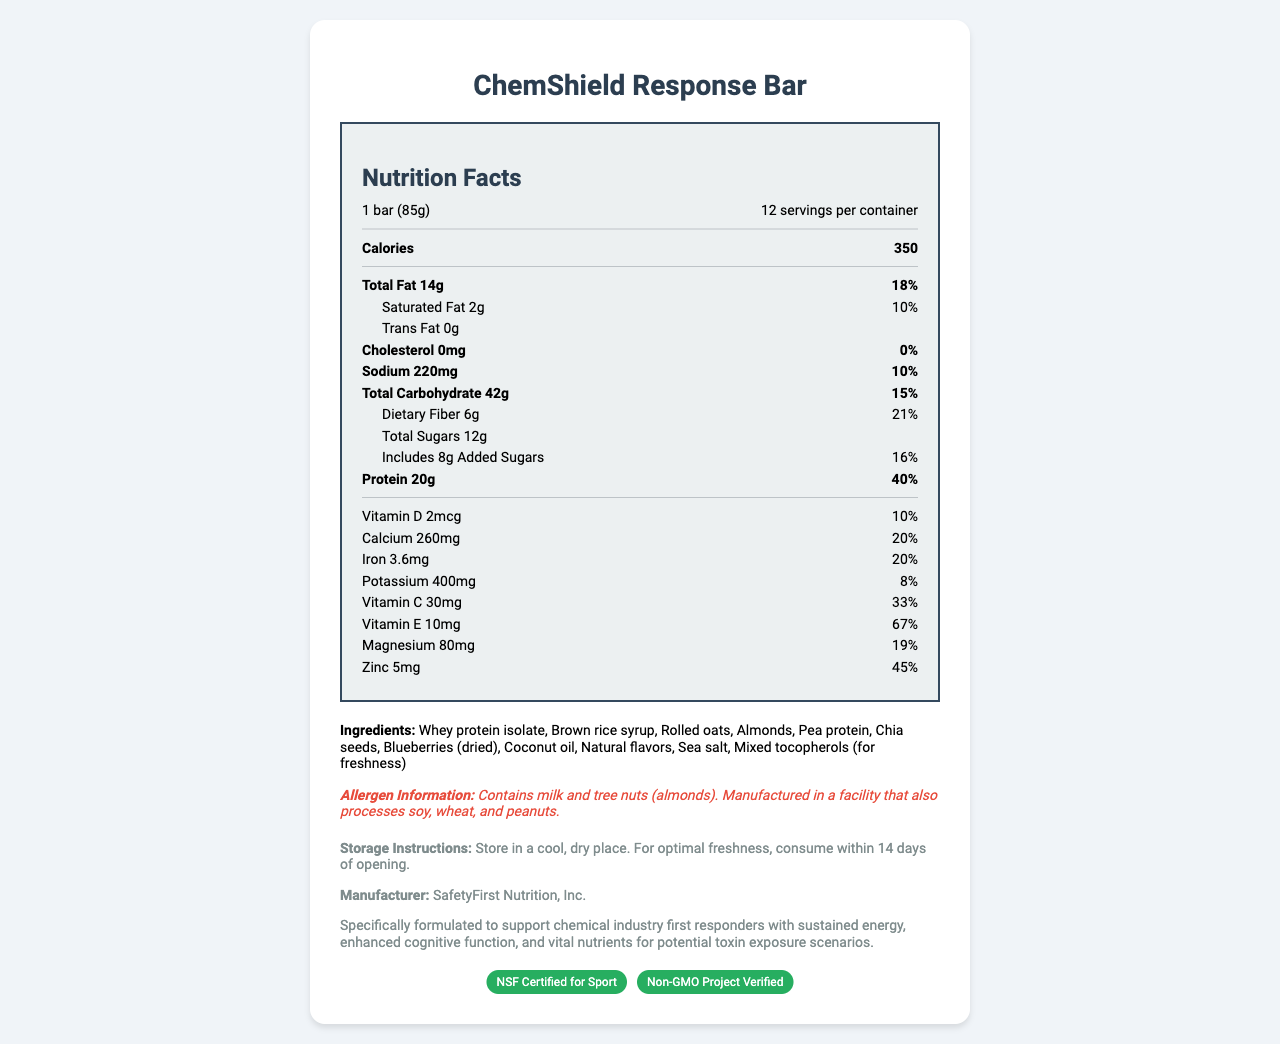what is the serving size? The serving size is listed as "1 bar (85g)" in the nutrition label section of the document.
Answer: 1 bar (85g) how many servings are there per container? The document states that there are 12 servings per container.
Answer: 12 servings what is the total fat content per serving? The document specifies "Total Fat 14g" under the nutrition facts.
Answer: 14g what is the protein content and its daily value percentage per serving? The protein content is indicated as "Protein 20g" with a daily value percentage of 40%.
Answer: 20g, 40% which ingredient is included for freshness? The ingredients list includes "Mixed tocopherols (for freshness)".
Answer: Mixed tocopherols how much sodium is in one serving, and what is its daily value percentage? One serving contains 220mg of sodium, which is 10% of the daily value.
Answer: 220mg, 10% how much added sugars in one serving and its daily value percentage? One serving includes 8g of added sugars, corresponding to 16% of the daily value.
Answer: 8g, 16% what vitamins are included in the ChemShield Response Bar? The nutrition facts list Vitamin D (2mcg), Vitamin C (30mg), and Vitamin E (10mg).
Answer: Vitamin D, Vitamin C, Vitamin E what are the certifications of the ChemShield Response Bar? The document mentions the certifications: "NSF Certified for Sport" and "Non-GMO Project Verified".
Answer: NSF Certified for Sport, Non-GMO Project Verified what allergens are present in this product? The allergen information specifies the presence of milk and tree nuts (almonds).
Answer: Contains milk and tree nuts (almonds) how much dietary fiber is in one serving, and what is the daily value percentage? The dietary fiber content is 6g per serving, which is 21% of the daily value.
Answer: 6g, 21% where should the ChemShield Response Bar be stored for optimal freshness? The storage instructions specify to store in a cool, dry place and consume within 14 days of opening.
Answer: Store in a cool, dry place. Consume within 14 days of opening. which certification badge is green in color? A. NSF Certified for Sport B. Non-GMO Project Verified C. Both D. Neither Both certification badges shown in the document are green.
Answer: C. Both what is the total carbohydrate amount per serving? The total carbohydrate amount is listed as 42g in the nutrition facts.
Answer: 42g does the product contain cholesterol? The nutrition label mentions "Cholesterol 0mg", which means the product contains no cholesterol.
Answer: No describe the main idea of this document This document includes a detailed nutrition label, lists ingredients and allergens, gives storage and manufacturer details, shows certifications, and explains the specialized formulation for chemical industry first responders.
Answer: The document provides comprehensive nutrition facts, ingredient details, allergen information, storage instructions, manufacturer details, certifications, and additional information specifically formulated for chemical industry first responders of the ChemShield Response Bar. what is the barcode number for the ChemShield Response Bar? The document does not provide any information regarding a barcode number.
Answer: Cannot be determined which nutrient has the highest daily value percentage? A. Protein B. Vitamin E C. Zinc D. Calcium Vitamin E has the highest daily value percentage at 67%, compared to Protein (40%), Zinc (45%), and Calcium (20%).
Answer: B. Vitamin E 